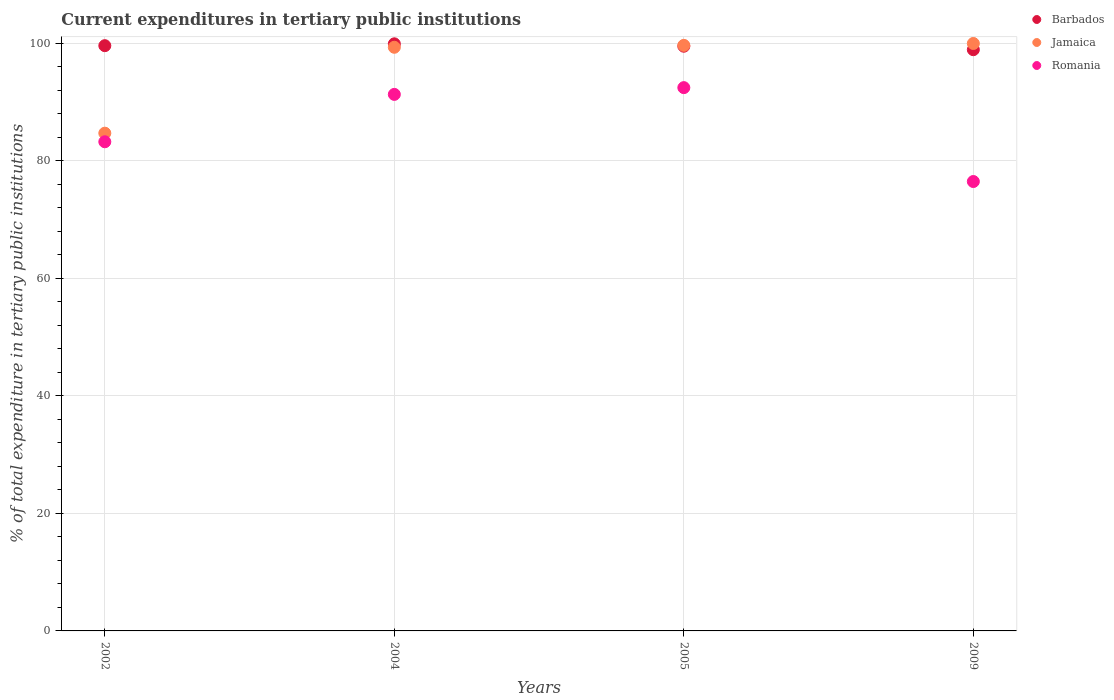What is the current expenditures in tertiary public institutions in Barbados in 2009?
Your response must be concise. 98.94. Across all years, what is the maximum current expenditures in tertiary public institutions in Jamaica?
Make the answer very short. 100. Across all years, what is the minimum current expenditures in tertiary public institutions in Romania?
Offer a very short reply. 76.5. In which year was the current expenditures in tertiary public institutions in Romania maximum?
Ensure brevity in your answer.  2005. What is the total current expenditures in tertiary public institutions in Jamaica in the graph?
Keep it short and to the point. 383.77. What is the difference between the current expenditures in tertiary public institutions in Romania in 2002 and that in 2005?
Your answer should be very brief. -9.21. What is the difference between the current expenditures in tertiary public institutions in Romania in 2005 and the current expenditures in tertiary public institutions in Jamaica in 2009?
Offer a very short reply. -7.52. What is the average current expenditures in tertiary public institutions in Romania per year?
Offer a terse response. 85.9. In the year 2002, what is the difference between the current expenditures in tertiary public institutions in Jamaica and current expenditures in tertiary public institutions in Barbados?
Provide a succinct answer. -14.9. What is the ratio of the current expenditures in tertiary public institutions in Romania in 2002 to that in 2004?
Offer a very short reply. 0.91. Is the current expenditures in tertiary public institutions in Romania in 2002 less than that in 2004?
Make the answer very short. Yes. What is the difference between the highest and the second highest current expenditures in tertiary public institutions in Barbados?
Offer a terse response. 0.31. What is the difference between the highest and the lowest current expenditures in tertiary public institutions in Romania?
Ensure brevity in your answer.  15.98. Is the sum of the current expenditures in tertiary public institutions in Jamaica in 2002 and 2005 greater than the maximum current expenditures in tertiary public institutions in Barbados across all years?
Keep it short and to the point. Yes. Is it the case that in every year, the sum of the current expenditures in tertiary public institutions in Barbados and current expenditures in tertiary public institutions in Romania  is greater than the current expenditures in tertiary public institutions in Jamaica?
Your response must be concise. Yes. What is the difference between two consecutive major ticks on the Y-axis?
Provide a short and direct response. 20. Does the graph contain any zero values?
Your answer should be compact. No. What is the title of the graph?
Keep it short and to the point. Current expenditures in tertiary public institutions. What is the label or title of the Y-axis?
Your response must be concise. % of total expenditure in tertiary public institutions. What is the % of total expenditure in tertiary public institutions in Barbados in 2002?
Your response must be concise. 99.63. What is the % of total expenditure in tertiary public institutions in Jamaica in 2002?
Give a very brief answer. 84.73. What is the % of total expenditure in tertiary public institutions of Romania in 2002?
Provide a short and direct response. 83.27. What is the % of total expenditure in tertiary public institutions of Barbados in 2004?
Make the answer very short. 99.94. What is the % of total expenditure in tertiary public institutions in Jamaica in 2004?
Make the answer very short. 99.35. What is the % of total expenditure in tertiary public institutions in Romania in 2004?
Provide a short and direct response. 91.33. What is the % of total expenditure in tertiary public institutions in Barbados in 2005?
Provide a short and direct response. 99.53. What is the % of total expenditure in tertiary public institutions in Jamaica in 2005?
Offer a very short reply. 99.68. What is the % of total expenditure in tertiary public institutions in Romania in 2005?
Your answer should be compact. 92.48. What is the % of total expenditure in tertiary public institutions of Barbados in 2009?
Ensure brevity in your answer.  98.94. What is the % of total expenditure in tertiary public institutions of Romania in 2009?
Keep it short and to the point. 76.5. Across all years, what is the maximum % of total expenditure in tertiary public institutions of Barbados?
Provide a succinct answer. 99.94. Across all years, what is the maximum % of total expenditure in tertiary public institutions of Jamaica?
Provide a short and direct response. 100. Across all years, what is the maximum % of total expenditure in tertiary public institutions in Romania?
Provide a short and direct response. 92.48. Across all years, what is the minimum % of total expenditure in tertiary public institutions in Barbados?
Ensure brevity in your answer.  98.94. Across all years, what is the minimum % of total expenditure in tertiary public institutions in Jamaica?
Offer a very short reply. 84.73. Across all years, what is the minimum % of total expenditure in tertiary public institutions of Romania?
Your answer should be very brief. 76.5. What is the total % of total expenditure in tertiary public institutions of Barbados in the graph?
Offer a terse response. 398.04. What is the total % of total expenditure in tertiary public institutions of Jamaica in the graph?
Provide a succinct answer. 383.77. What is the total % of total expenditure in tertiary public institutions in Romania in the graph?
Offer a very short reply. 343.58. What is the difference between the % of total expenditure in tertiary public institutions in Barbados in 2002 and that in 2004?
Your response must be concise. -0.31. What is the difference between the % of total expenditure in tertiary public institutions in Jamaica in 2002 and that in 2004?
Offer a very short reply. -14.62. What is the difference between the % of total expenditure in tertiary public institutions of Romania in 2002 and that in 2004?
Give a very brief answer. -8.06. What is the difference between the % of total expenditure in tertiary public institutions of Barbados in 2002 and that in 2005?
Offer a very short reply. 0.09. What is the difference between the % of total expenditure in tertiary public institutions of Jamaica in 2002 and that in 2005?
Ensure brevity in your answer.  -14.95. What is the difference between the % of total expenditure in tertiary public institutions of Romania in 2002 and that in 2005?
Your answer should be compact. -9.21. What is the difference between the % of total expenditure in tertiary public institutions of Barbados in 2002 and that in 2009?
Your response must be concise. 0.69. What is the difference between the % of total expenditure in tertiary public institutions in Jamaica in 2002 and that in 2009?
Offer a very short reply. -15.27. What is the difference between the % of total expenditure in tertiary public institutions in Romania in 2002 and that in 2009?
Give a very brief answer. 6.77. What is the difference between the % of total expenditure in tertiary public institutions in Barbados in 2004 and that in 2005?
Provide a short and direct response. 0.41. What is the difference between the % of total expenditure in tertiary public institutions in Jamaica in 2004 and that in 2005?
Give a very brief answer. -0.33. What is the difference between the % of total expenditure in tertiary public institutions in Romania in 2004 and that in 2005?
Offer a terse response. -1.15. What is the difference between the % of total expenditure in tertiary public institutions of Jamaica in 2004 and that in 2009?
Make the answer very short. -0.65. What is the difference between the % of total expenditure in tertiary public institutions in Romania in 2004 and that in 2009?
Offer a terse response. 14.83. What is the difference between the % of total expenditure in tertiary public institutions of Barbados in 2005 and that in 2009?
Provide a short and direct response. 0.59. What is the difference between the % of total expenditure in tertiary public institutions of Jamaica in 2005 and that in 2009?
Offer a terse response. -0.32. What is the difference between the % of total expenditure in tertiary public institutions of Romania in 2005 and that in 2009?
Provide a short and direct response. 15.98. What is the difference between the % of total expenditure in tertiary public institutions in Barbados in 2002 and the % of total expenditure in tertiary public institutions in Jamaica in 2004?
Make the answer very short. 0.27. What is the difference between the % of total expenditure in tertiary public institutions of Barbados in 2002 and the % of total expenditure in tertiary public institutions of Romania in 2004?
Offer a very short reply. 8.29. What is the difference between the % of total expenditure in tertiary public institutions of Jamaica in 2002 and the % of total expenditure in tertiary public institutions of Romania in 2004?
Your response must be concise. -6.6. What is the difference between the % of total expenditure in tertiary public institutions of Barbados in 2002 and the % of total expenditure in tertiary public institutions of Jamaica in 2005?
Keep it short and to the point. -0.05. What is the difference between the % of total expenditure in tertiary public institutions of Barbados in 2002 and the % of total expenditure in tertiary public institutions of Romania in 2005?
Provide a succinct answer. 7.14. What is the difference between the % of total expenditure in tertiary public institutions in Jamaica in 2002 and the % of total expenditure in tertiary public institutions in Romania in 2005?
Your response must be concise. -7.75. What is the difference between the % of total expenditure in tertiary public institutions of Barbados in 2002 and the % of total expenditure in tertiary public institutions of Jamaica in 2009?
Provide a succinct answer. -0.37. What is the difference between the % of total expenditure in tertiary public institutions in Barbados in 2002 and the % of total expenditure in tertiary public institutions in Romania in 2009?
Your answer should be compact. 23.13. What is the difference between the % of total expenditure in tertiary public institutions in Jamaica in 2002 and the % of total expenditure in tertiary public institutions in Romania in 2009?
Provide a short and direct response. 8.23. What is the difference between the % of total expenditure in tertiary public institutions of Barbados in 2004 and the % of total expenditure in tertiary public institutions of Jamaica in 2005?
Offer a terse response. 0.26. What is the difference between the % of total expenditure in tertiary public institutions of Barbados in 2004 and the % of total expenditure in tertiary public institutions of Romania in 2005?
Give a very brief answer. 7.46. What is the difference between the % of total expenditure in tertiary public institutions in Jamaica in 2004 and the % of total expenditure in tertiary public institutions in Romania in 2005?
Your response must be concise. 6.87. What is the difference between the % of total expenditure in tertiary public institutions in Barbados in 2004 and the % of total expenditure in tertiary public institutions in Jamaica in 2009?
Your response must be concise. -0.06. What is the difference between the % of total expenditure in tertiary public institutions of Barbados in 2004 and the % of total expenditure in tertiary public institutions of Romania in 2009?
Give a very brief answer. 23.44. What is the difference between the % of total expenditure in tertiary public institutions of Jamaica in 2004 and the % of total expenditure in tertiary public institutions of Romania in 2009?
Make the answer very short. 22.85. What is the difference between the % of total expenditure in tertiary public institutions in Barbados in 2005 and the % of total expenditure in tertiary public institutions in Jamaica in 2009?
Your answer should be compact. -0.47. What is the difference between the % of total expenditure in tertiary public institutions of Barbados in 2005 and the % of total expenditure in tertiary public institutions of Romania in 2009?
Offer a very short reply. 23.03. What is the difference between the % of total expenditure in tertiary public institutions of Jamaica in 2005 and the % of total expenditure in tertiary public institutions of Romania in 2009?
Provide a succinct answer. 23.18. What is the average % of total expenditure in tertiary public institutions of Barbados per year?
Offer a very short reply. 99.51. What is the average % of total expenditure in tertiary public institutions of Jamaica per year?
Give a very brief answer. 95.94. What is the average % of total expenditure in tertiary public institutions of Romania per year?
Keep it short and to the point. 85.9. In the year 2002, what is the difference between the % of total expenditure in tertiary public institutions of Barbados and % of total expenditure in tertiary public institutions of Jamaica?
Offer a very short reply. 14.9. In the year 2002, what is the difference between the % of total expenditure in tertiary public institutions of Barbados and % of total expenditure in tertiary public institutions of Romania?
Make the answer very short. 16.36. In the year 2002, what is the difference between the % of total expenditure in tertiary public institutions in Jamaica and % of total expenditure in tertiary public institutions in Romania?
Your answer should be very brief. 1.46. In the year 2004, what is the difference between the % of total expenditure in tertiary public institutions in Barbados and % of total expenditure in tertiary public institutions in Jamaica?
Give a very brief answer. 0.59. In the year 2004, what is the difference between the % of total expenditure in tertiary public institutions of Barbados and % of total expenditure in tertiary public institutions of Romania?
Make the answer very short. 8.61. In the year 2004, what is the difference between the % of total expenditure in tertiary public institutions of Jamaica and % of total expenditure in tertiary public institutions of Romania?
Your answer should be compact. 8.02. In the year 2005, what is the difference between the % of total expenditure in tertiary public institutions in Barbados and % of total expenditure in tertiary public institutions in Jamaica?
Your answer should be compact. -0.15. In the year 2005, what is the difference between the % of total expenditure in tertiary public institutions of Barbados and % of total expenditure in tertiary public institutions of Romania?
Give a very brief answer. 7.05. In the year 2005, what is the difference between the % of total expenditure in tertiary public institutions of Jamaica and % of total expenditure in tertiary public institutions of Romania?
Your answer should be compact. 7.2. In the year 2009, what is the difference between the % of total expenditure in tertiary public institutions in Barbados and % of total expenditure in tertiary public institutions in Jamaica?
Provide a succinct answer. -1.06. In the year 2009, what is the difference between the % of total expenditure in tertiary public institutions in Barbados and % of total expenditure in tertiary public institutions in Romania?
Keep it short and to the point. 22.44. In the year 2009, what is the difference between the % of total expenditure in tertiary public institutions in Jamaica and % of total expenditure in tertiary public institutions in Romania?
Offer a very short reply. 23.5. What is the ratio of the % of total expenditure in tertiary public institutions in Jamaica in 2002 to that in 2004?
Offer a terse response. 0.85. What is the ratio of the % of total expenditure in tertiary public institutions of Romania in 2002 to that in 2004?
Offer a terse response. 0.91. What is the ratio of the % of total expenditure in tertiary public institutions in Romania in 2002 to that in 2005?
Provide a short and direct response. 0.9. What is the ratio of the % of total expenditure in tertiary public institutions of Barbados in 2002 to that in 2009?
Offer a terse response. 1.01. What is the ratio of the % of total expenditure in tertiary public institutions in Jamaica in 2002 to that in 2009?
Ensure brevity in your answer.  0.85. What is the ratio of the % of total expenditure in tertiary public institutions of Romania in 2002 to that in 2009?
Offer a very short reply. 1.09. What is the ratio of the % of total expenditure in tertiary public institutions of Barbados in 2004 to that in 2005?
Offer a terse response. 1. What is the ratio of the % of total expenditure in tertiary public institutions of Romania in 2004 to that in 2005?
Your answer should be compact. 0.99. What is the ratio of the % of total expenditure in tertiary public institutions of Barbados in 2004 to that in 2009?
Keep it short and to the point. 1.01. What is the ratio of the % of total expenditure in tertiary public institutions in Jamaica in 2004 to that in 2009?
Keep it short and to the point. 0.99. What is the ratio of the % of total expenditure in tertiary public institutions in Romania in 2004 to that in 2009?
Provide a short and direct response. 1.19. What is the ratio of the % of total expenditure in tertiary public institutions of Barbados in 2005 to that in 2009?
Provide a succinct answer. 1.01. What is the ratio of the % of total expenditure in tertiary public institutions of Jamaica in 2005 to that in 2009?
Give a very brief answer. 1. What is the ratio of the % of total expenditure in tertiary public institutions in Romania in 2005 to that in 2009?
Provide a succinct answer. 1.21. What is the difference between the highest and the second highest % of total expenditure in tertiary public institutions in Barbados?
Provide a succinct answer. 0.31. What is the difference between the highest and the second highest % of total expenditure in tertiary public institutions in Jamaica?
Your response must be concise. 0.32. What is the difference between the highest and the second highest % of total expenditure in tertiary public institutions in Romania?
Provide a succinct answer. 1.15. What is the difference between the highest and the lowest % of total expenditure in tertiary public institutions of Barbados?
Give a very brief answer. 1. What is the difference between the highest and the lowest % of total expenditure in tertiary public institutions in Jamaica?
Ensure brevity in your answer.  15.27. What is the difference between the highest and the lowest % of total expenditure in tertiary public institutions in Romania?
Give a very brief answer. 15.98. 